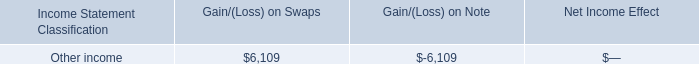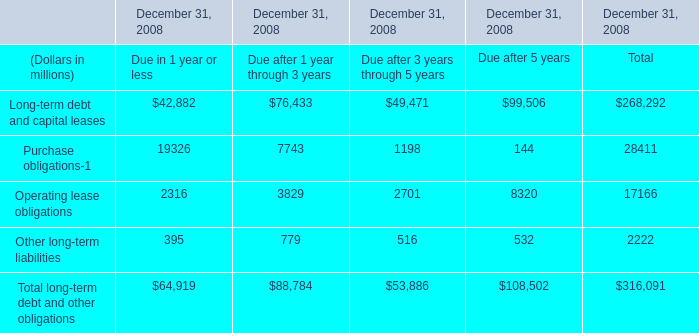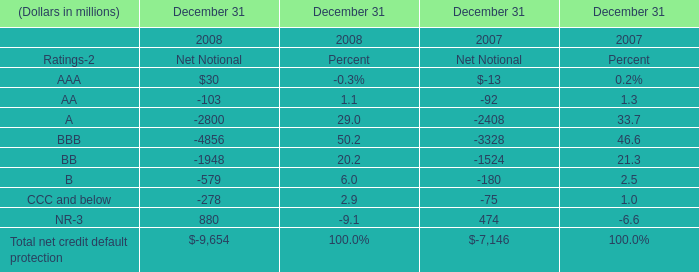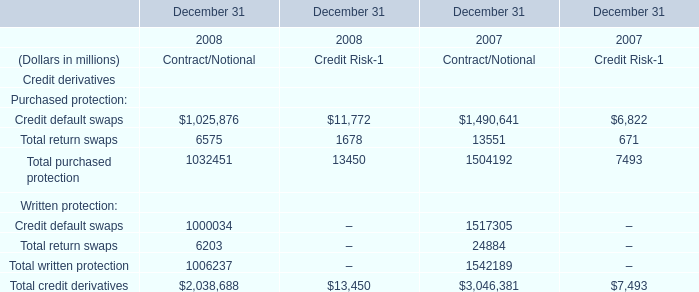What's the average of the Total net credit default protection in the years where AAA is positive? (in million) 
Computations: (9654 / 8)
Answer: 1206.75. 